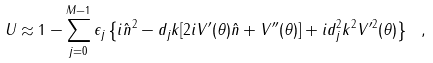<formula> <loc_0><loc_0><loc_500><loc_500>U \approx 1 - \sum _ { j = 0 } ^ { M - 1 } \epsilon _ { j } \left \{ i { \hat { n } } ^ { 2 } - d _ { j } k [ 2 i V ^ { \prime } ( \theta ) { \hat { n } } + V ^ { \prime \prime } ( \theta ) ] + i d _ { j } ^ { 2 } k ^ { 2 } V ^ { \prime 2 } ( \theta ) \right \} \ ,</formula> 